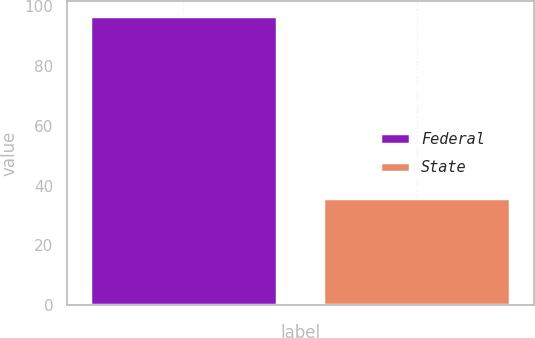Convert chart to OTSL. <chart><loc_0><loc_0><loc_500><loc_500><bar_chart><fcel>Federal<fcel>State<nl><fcel>96.6<fcel>35.8<nl></chart> 